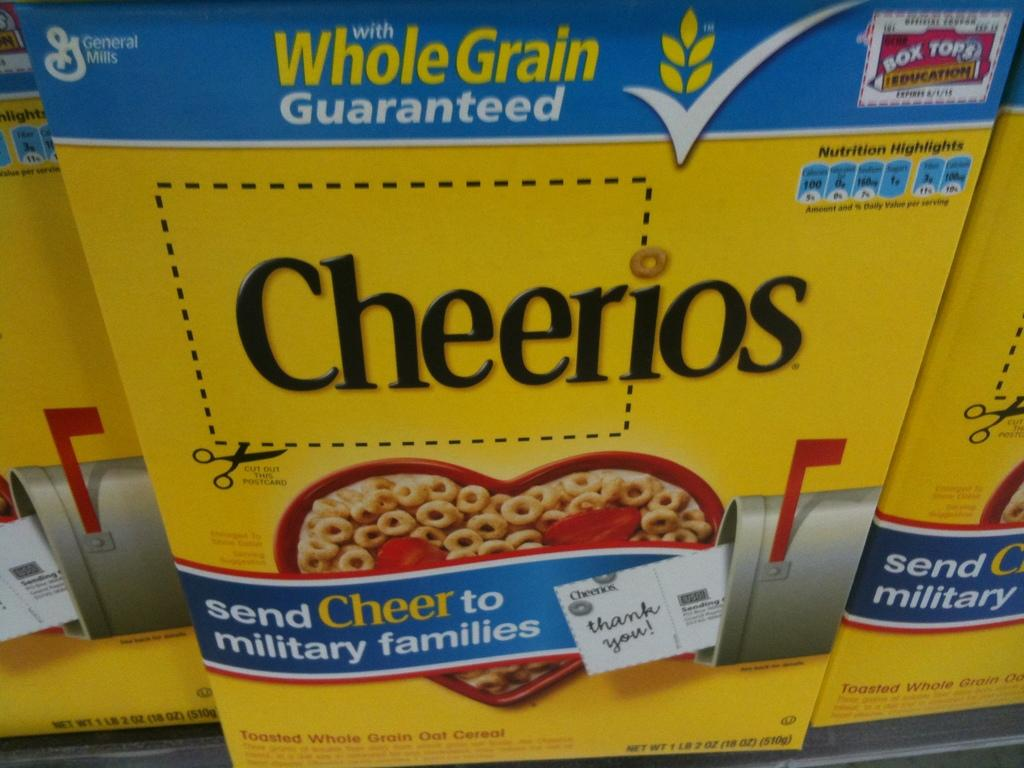<image>
Provide a brief description of the given image. A box of Cheerios, whole grain guaranteed with box tops 